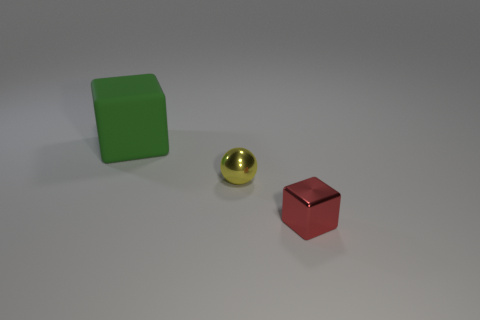Is there any other thing that is the same size as the green cube?
Your answer should be very brief. No. Are there the same number of large rubber things on the left side of the big green matte block and blue cylinders?
Make the answer very short. Yes. Is the size of the yellow ball the same as the red shiny object?
Your answer should be very brief. Yes. How many other metallic things have the same shape as the small yellow object?
Provide a short and direct response. 0. What is the block on the left side of the red metallic thing made of?
Your answer should be very brief. Rubber. Are there fewer green blocks on the right side of the small red metal thing than tiny matte objects?
Your response must be concise. No. Does the tiny yellow thing have the same shape as the large green object?
Offer a very short reply. No. Are there any other things that have the same shape as the small yellow metallic object?
Provide a short and direct response. No. Is there a tiny shiny thing?
Your answer should be very brief. Yes. Do the big rubber thing and the tiny object that is to the right of the yellow thing have the same shape?
Your answer should be very brief. Yes. 